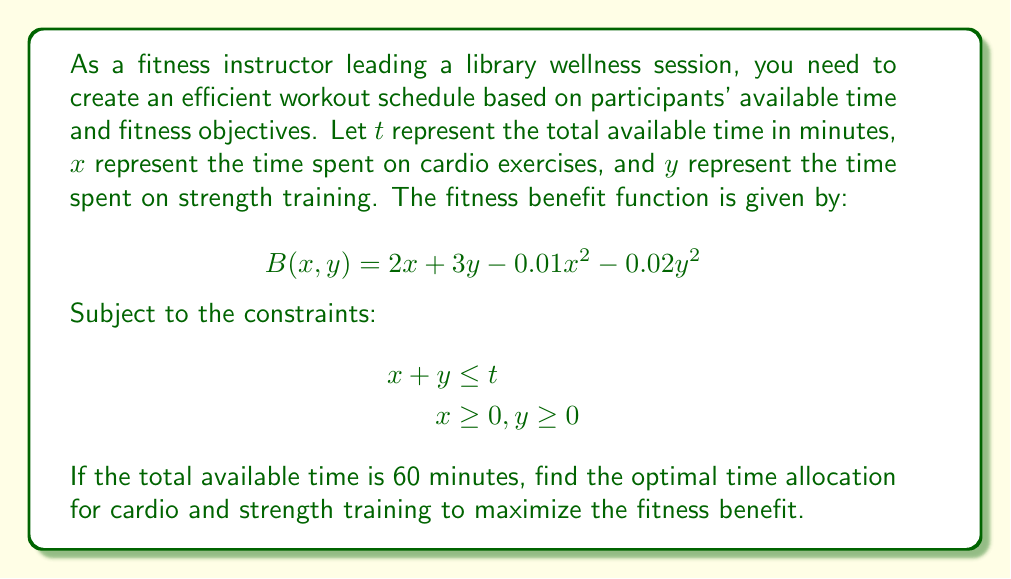Provide a solution to this math problem. To solve this optimization problem, we'll use the method of Lagrange multipliers:

1) First, we form the Lagrangian function:
   $$L(x, y, \lambda) = 2x + 3y - 0.01x^2 - 0.02y^2 + \lambda(t - x - y)$$

2) We then find the partial derivatives and set them to zero:
   $$\frac{\partial L}{\partial x} = 2 - 0.02x - \lambda = 0$$
   $$\frac{\partial L}{\partial y} = 3 - 0.04y - \lambda = 0$$
   $$\frac{\partial L}{\partial \lambda} = t - x - y = 0$$

3) From the first two equations:
   $$2 - 0.02x = 3 - 0.04y$$
   $$0.02x = 1 + 0.04y$$
   $$x = 50 + 2y$$

4) Substituting this into the constraint equation:
   $$(50 + 2y) + y = 60$$
   $$3y = 10$$
   $$y = \frac{10}{3} \approx 3.33$$

5) Then we can find x:
   $$x = 50 + 2(\frac{10}{3}) = \frac{170}{3} \approx 56.67$$

6) We can verify that this satisfies the constraint:
   $$56.67 + 3.33 = 60$$

7) To confirm this is a maximum, we can check the second derivatives:
   $$\frac{\partial^2 L}{\partial x^2} = -0.02 < 0$$
   $$\frac{\partial^2 L}{\partial y^2} = -0.04 < 0$$

   The negative second derivatives confirm this is indeed a maximum.
Answer: The optimal time allocation is approximately 56.67 minutes for cardio exercises and 3.33 minutes for strength training. 